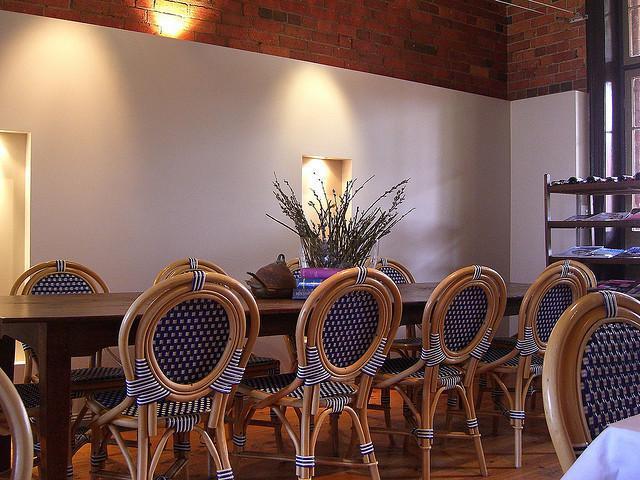How many dining tables are in the picture?
Give a very brief answer. 2. How many chairs can be seen?
Give a very brief answer. 7. 